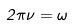<formula> <loc_0><loc_0><loc_500><loc_500>2 \pi \nu = \omega</formula> 